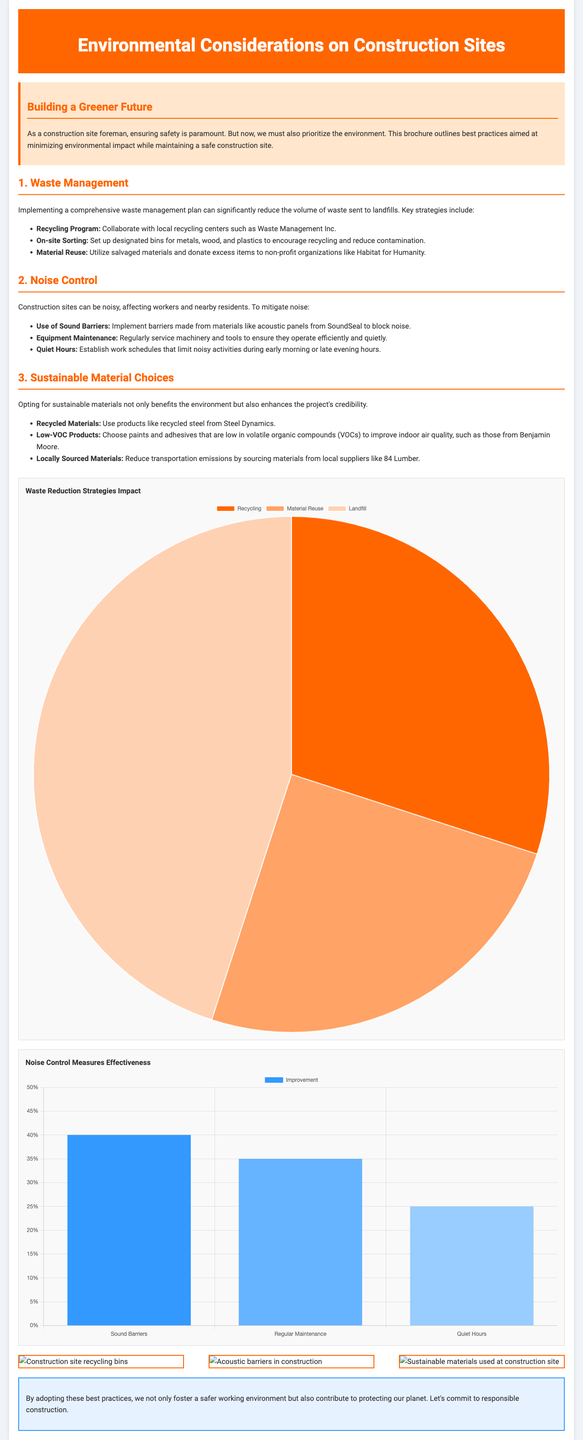What is the first section of the brochure about? The first section discusses waste management strategies to minimize environmental impact.
Answer: Waste Management How many key strategies are mentioned under waste management? Three key strategies are outlined in the waste management section.
Answer: Three What is one recyclable material mentioned for construction? The brochure mentions recycled steel as a sustainable material choice.
Answer: Recycled Steel What percentage improvement is associated with the use of sound barriers? The chart shows a 40% improvement due to the implementation of sound barriers.
Answer: 40% Which organization can receive donated excess items? The document mentions that Habitat for Humanity can receive donated items.
Answer: Habitat for Humanity What color is the header of the brochure? The header background color is orange.
Answer: Orange What is the main goal of the brochure as stated in the introduction? The brochure aims to prioritize the environment alongside safety on construction sites.
Answer: Prioritize the environment How many effectiveness measures are included in the noise control section? There are three measures listed to control noise on construction sites.
Answer: Three What type of chart is used to display waste reduction strategies? The waste reduction strategies chart is of the pie chart type.
Answer: Pie What is the conclusion about adopting best practices in construction? The conclusion states that adopting best practices contributes to protecting the planet.
Answer: Protecting the planet 